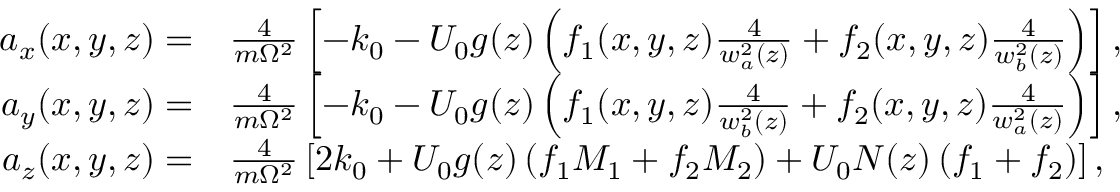Convert formula to latex. <formula><loc_0><loc_0><loc_500><loc_500>\begin{array} { r l } { a _ { x } ( x , y , z ) = } & { \frac { 4 } { m \Omega ^ { 2 } } \left [ - k _ { 0 } - U _ { 0 } g ( z ) \left ( f _ { 1 } ( x , y , z ) \frac { 4 } { w _ { a } ^ { 2 } ( z ) } + f _ { 2 } ( x , y , z ) \frac { 4 } { w _ { b } ^ { 2 } ( z ) } \right ) \right ] , } \\ { a _ { y } ( x , y , z ) = } & { \frac { 4 } { m \Omega ^ { 2 } } \left [ - k _ { 0 } - U _ { 0 } g ( z ) \left ( f _ { 1 } ( x , y , z ) \frac { 4 } { w _ { b } ^ { 2 } ( z ) } + f _ { 2 } ( x , y , z ) \frac { 4 } { w _ { a } ^ { 2 } ( z ) } \right ) \right ] , } \\ { a _ { z } ( x , y , z ) = } & { \frac { 4 } { m \Omega ^ { 2 } } \left [ 2 k _ { 0 } + U _ { 0 } g ( z ) \left ( f _ { 1 } M _ { 1 } + f _ { 2 } M _ { 2 } \right ) + U _ { 0 } N ( z ) \left ( f _ { 1 } + f _ { 2 } \right ) \right ] , } \end{array}</formula> 